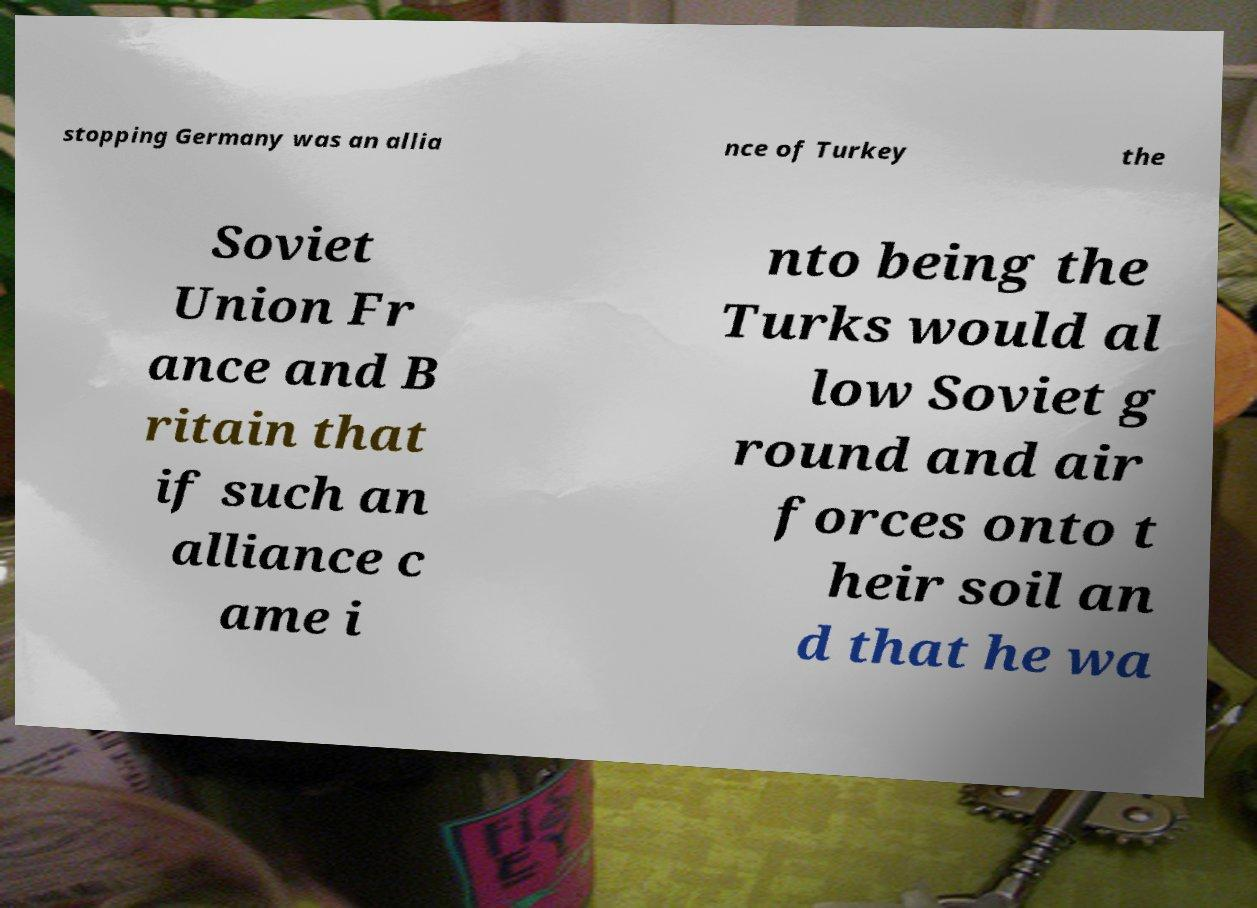Could you assist in decoding the text presented in this image and type it out clearly? stopping Germany was an allia nce of Turkey the Soviet Union Fr ance and B ritain that if such an alliance c ame i nto being the Turks would al low Soviet g round and air forces onto t heir soil an d that he wa 